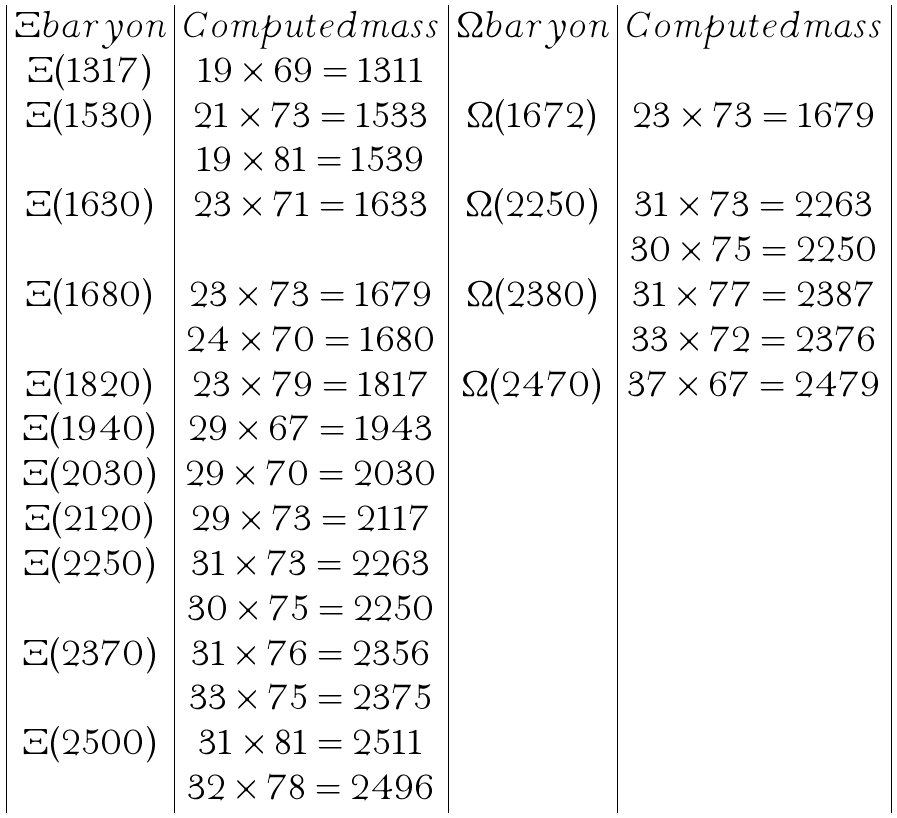Convert formula to latex. <formula><loc_0><loc_0><loc_500><loc_500>\begin{array} { | c | c | c | c | } \Xi b a r y o n & C o m p u t e d m a s s & \Omega b a r y o n & C o m p u t e d m a s s \\ \Xi ( 1 3 1 7 ) & { 1 9 } \times 6 9 = 1 3 1 1 & & \\ \Xi ( 1 5 3 0 ) & 2 1 \times 7 3 = 1 5 3 3 & \Omega ( 1 6 7 2 ) & { 2 3 } \times 7 3 = 1 6 7 9 \\ & { 1 9 } \times 8 1 = 1 5 3 9 & & \\ \Xi ( 1 6 3 0 ) & { 2 3 } \times 7 1 = 1 6 3 3 & \Omega ( 2 2 5 0 ) & { 3 1 } \times 7 3 = 2 2 6 3 \\ & & & 3 0 \times 7 5 = 2 2 5 0 \\ \Xi ( 1 6 8 0 ) & { 2 3 } \times 7 3 = 1 6 7 9 & \Omega ( 2 3 8 0 ) & { 3 1 } \times 7 7 = 2 3 8 7 \\ & 2 4 \times 7 0 = 1 6 8 0 & & 3 3 \times 7 2 = 2 3 7 6 \\ \Xi ( 1 8 2 0 ) & { 2 3 } \times 7 9 = 1 8 1 7 & \Omega ( 2 4 7 0 ) & { 3 7 } \times 6 7 = 2 4 7 9 \\ \Xi ( 1 9 4 0 ) & { 2 9 } \times 6 7 = 1 9 4 3 & & \\ \Xi ( 2 0 3 0 ) & { 2 9 } \times 7 0 = 2 0 3 0 & & \\ \Xi ( 2 1 2 0 ) & { 2 9 } \times 7 3 = 2 1 1 7 & & \\ \Xi ( 2 2 5 0 ) & { 3 1 } \times 7 3 = 2 2 6 3 & & \\ & 3 0 \times 7 5 = 2 2 5 0 & & \\ \Xi ( 2 3 7 0 ) & { 3 1 } \times 7 6 = 2 3 5 6 & & \\ & 3 3 \times 7 5 = 2 3 7 5 & & \\ \Xi ( 2 5 0 0 ) & { 3 1 } \times 8 1 = 2 5 1 1 & & \\ & 3 2 \times 7 8 = 2 4 9 6 & & \\ \end{array}</formula> 